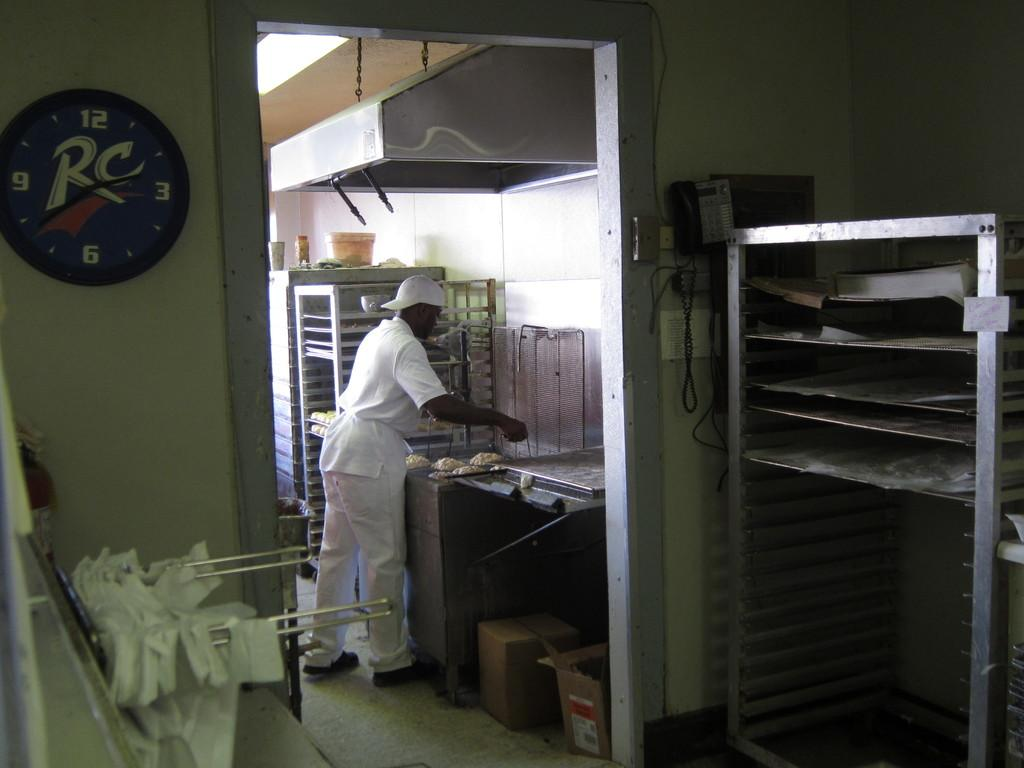<image>
Relay a brief, clear account of the picture shown. Man wearing white cooking in a room that has a RC clock. 